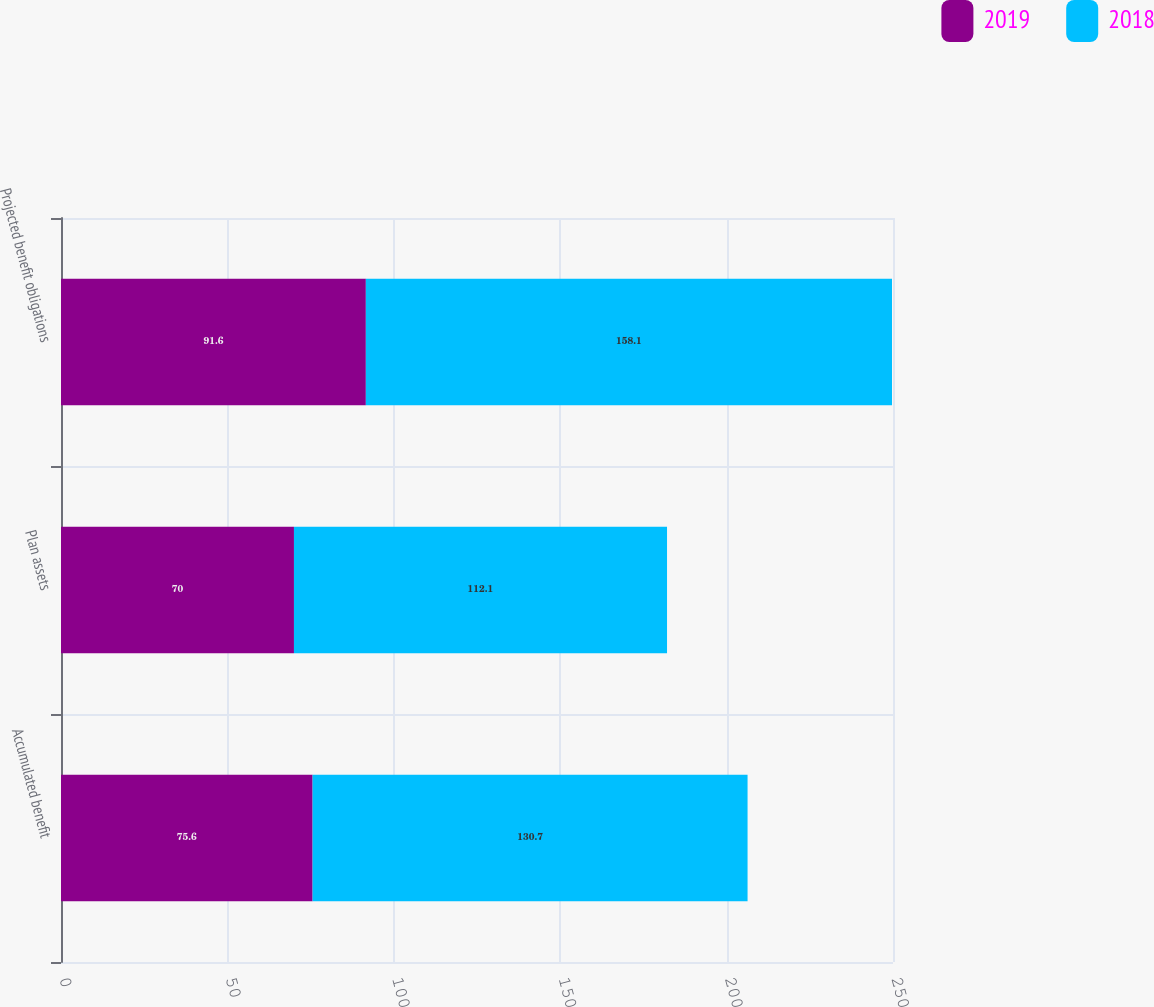Convert chart to OTSL. <chart><loc_0><loc_0><loc_500><loc_500><stacked_bar_chart><ecel><fcel>Accumulated benefit<fcel>Plan assets<fcel>Projected benefit obligations<nl><fcel>2019<fcel>75.6<fcel>70<fcel>91.6<nl><fcel>2018<fcel>130.7<fcel>112.1<fcel>158.1<nl></chart> 